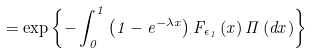<formula> <loc_0><loc_0><loc_500><loc_500>= \exp \left \{ - \int _ { 0 } ^ { 1 } \left ( 1 - e ^ { - \lambda x } \right ) F _ { \epsilon _ { 1 } } \left ( x \right ) \Pi \left ( d x \right ) \right \}</formula> 